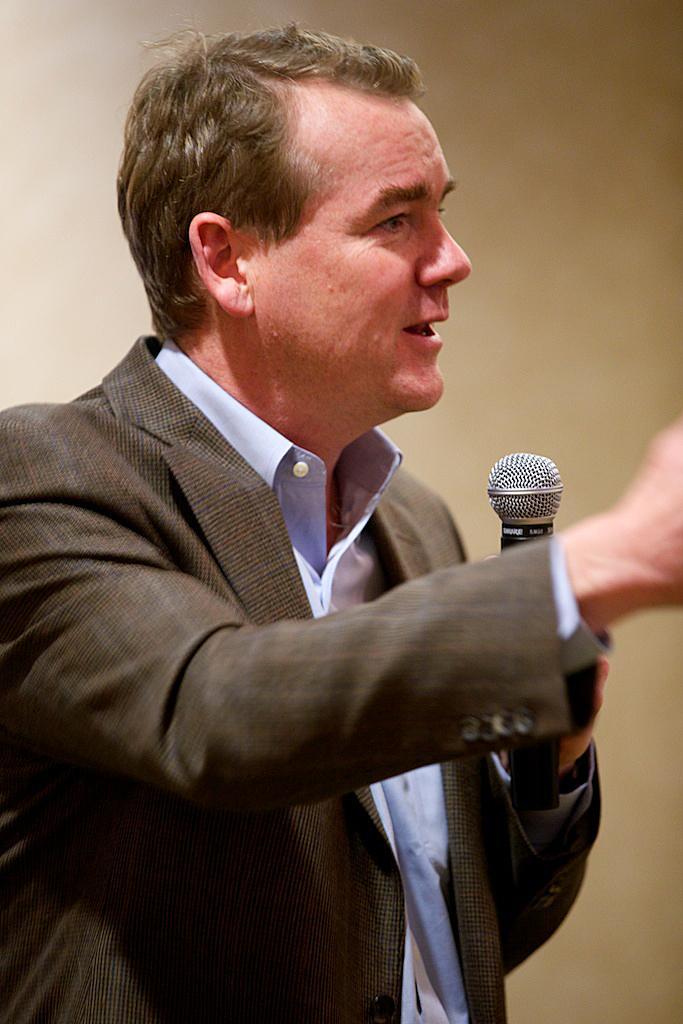Please provide a concise description of this image. As we can see in the image there is a white color wall and a man holding mic. 